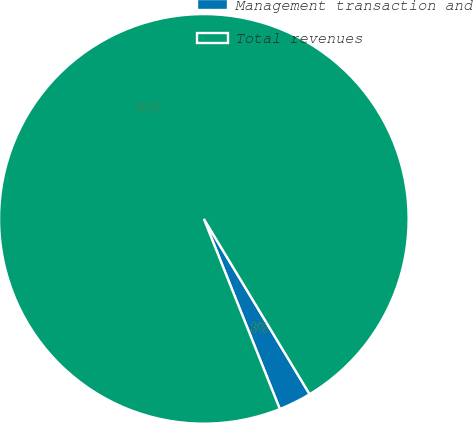<chart> <loc_0><loc_0><loc_500><loc_500><pie_chart><fcel>Management transaction and<fcel>Total revenues<nl><fcel>2.59%<fcel>97.41%<nl></chart> 